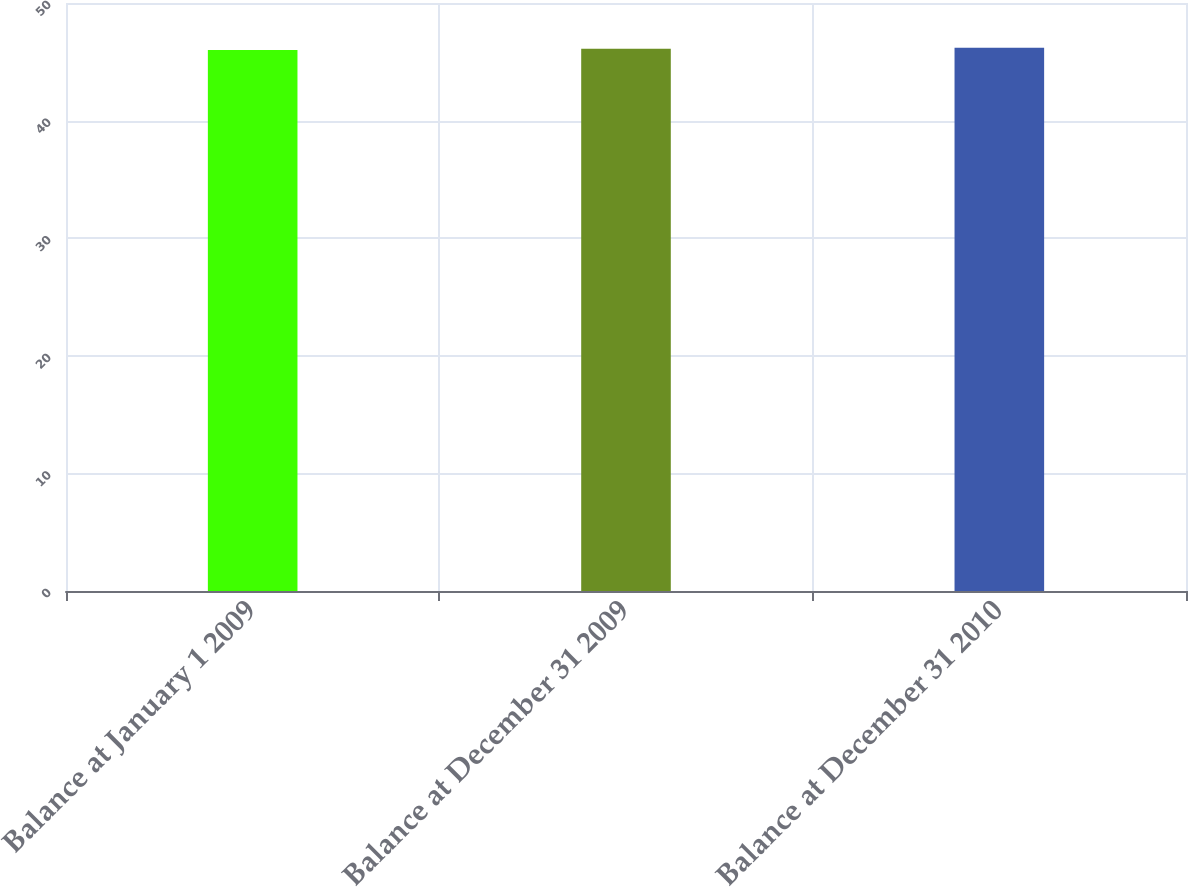Convert chart. <chart><loc_0><loc_0><loc_500><loc_500><bar_chart><fcel>Balance at January 1 2009<fcel>Balance at December 31 2009<fcel>Balance at December 31 2010<nl><fcel>46<fcel>46.1<fcel>46.2<nl></chart> 